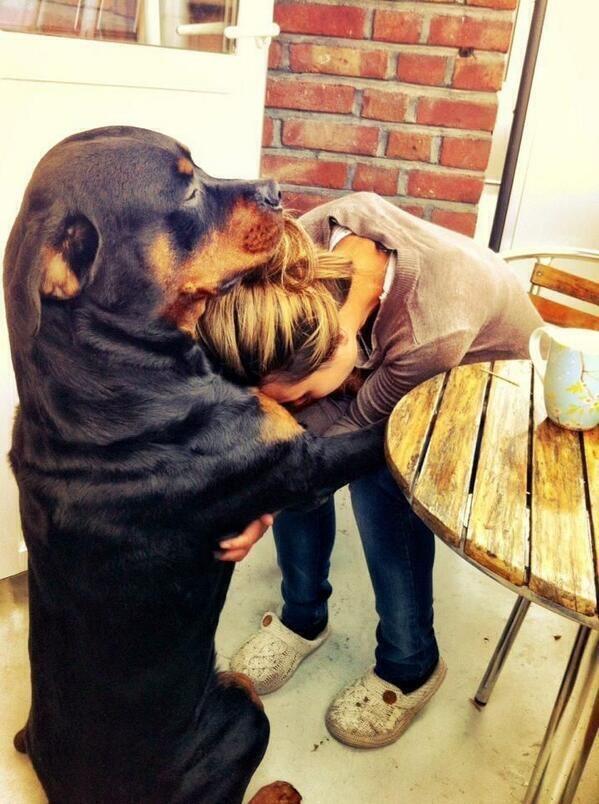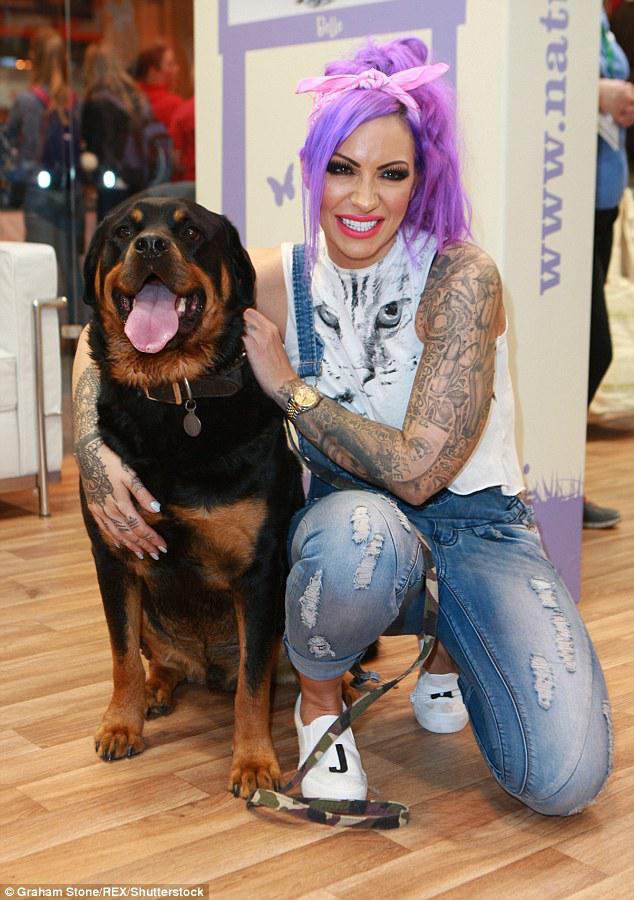The first image is the image on the left, the second image is the image on the right. Given the left and right images, does the statement "There are three dogs." hold true? Answer yes or no. No. The first image is the image on the left, the second image is the image on the right. Evaluate the accuracy of this statement regarding the images: "A total of three dogs, all standing, are shown, and at least two dogs are dobermans with erect pointy ears.". Is it true? Answer yes or no. No. 